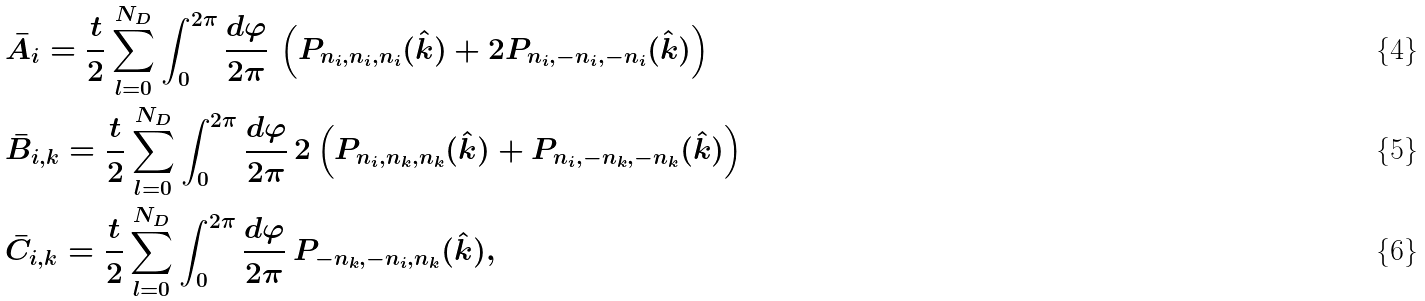<formula> <loc_0><loc_0><loc_500><loc_500>& \bar { A } _ { i } = \frac { t } { 2 } \sum _ { l = 0 } ^ { N _ { D } } \int _ { 0 } ^ { 2 \pi } \frac { d \varphi } { 2 \pi } \, \left ( P _ { n _ { i } , n _ { i } , n _ { i } } ( \hat { k } ) + 2 P _ { n _ { i } , - n _ { i } , - n _ { i } } ( \hat { k } ) \right ) \\ & \bar { B } _ { i , k } = \frac { t } { 2 } \sum _ { l = 0 } ^ { N _ { D } } \int _ { 0 } ^ { 2 \pi } \frac { d \varphi } { 2 \pi } \, 2 \left ( P _ { n _ { i } , n _ { k } , n _ { k } } ( \hat { k } ) + P _ { n _ { i } , - n _ { k } , - n _ { k } } ( \hat { k } ) \right ) \\ & \bar { C } _ { i , k } = \frac { t } { 2 } \sum _ { l = 0 } ^ { N _ { D } } \int _ { 0 } ^ { 2 \pi } \frac { d \varphi } { 2 \pi } \, P _ { - n _ { k } , - n _ { i } , n _ { k } } ( \hat { k } ) ,</formula> 